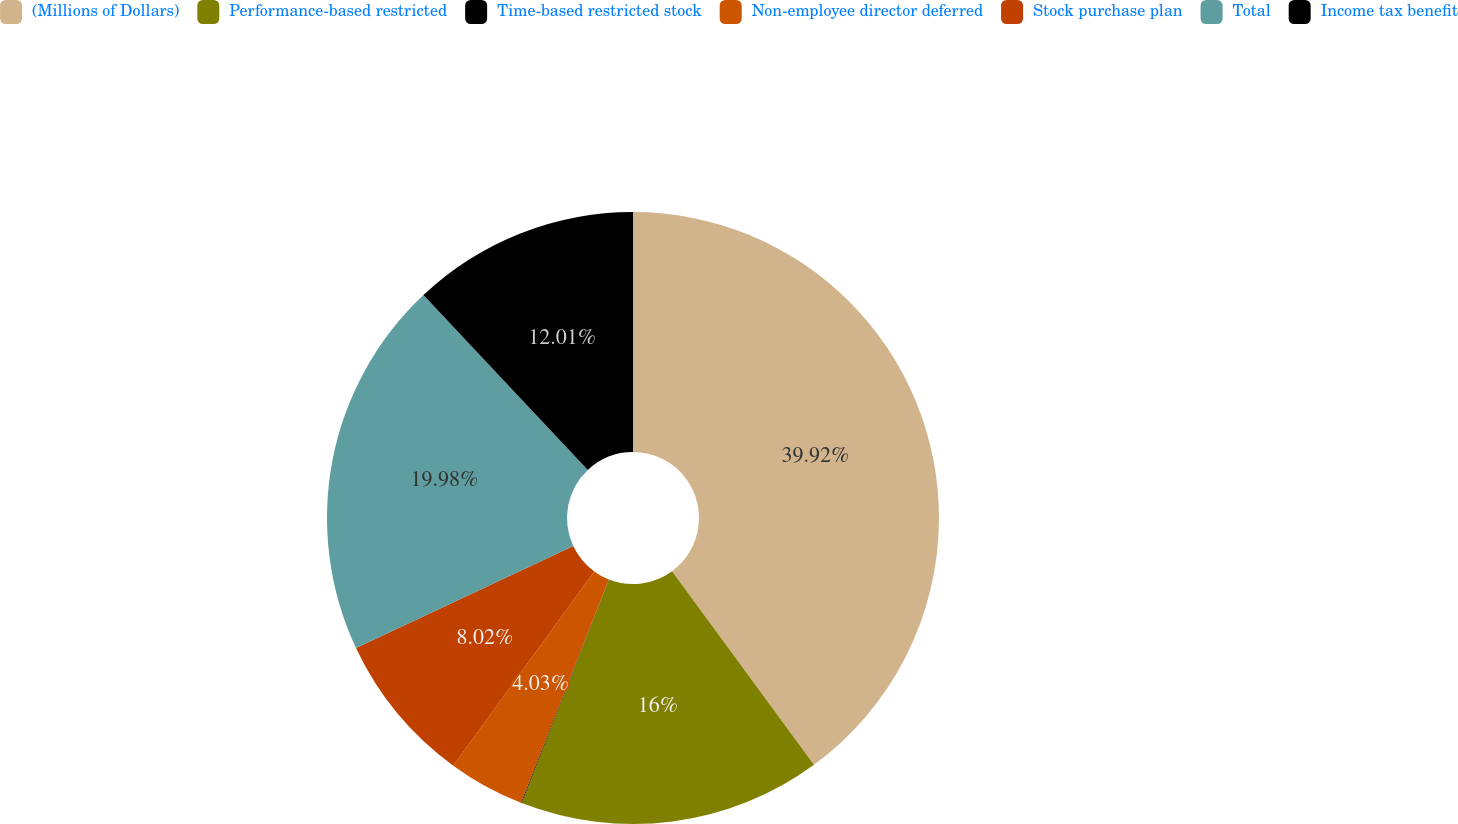Convert chart to OTSL. <chart><loc_0><loc_0><loc_500><loc_500><pie_chart><fcel>(Millions of Dollars)<fcel>Performance-based restricted<fcel>Time-based restricted stock<fcel>Non-employee director deferred<fcel>Stock purchase plan<fcel>Total<fcel>Income tax benefit<nl><fcel>39.93%<fcel>16.0%<fcel>0.04%<fcel>4.03%<fcel>8.02%<fcel>19.98%<fcel>12.01%<nl></chart> 